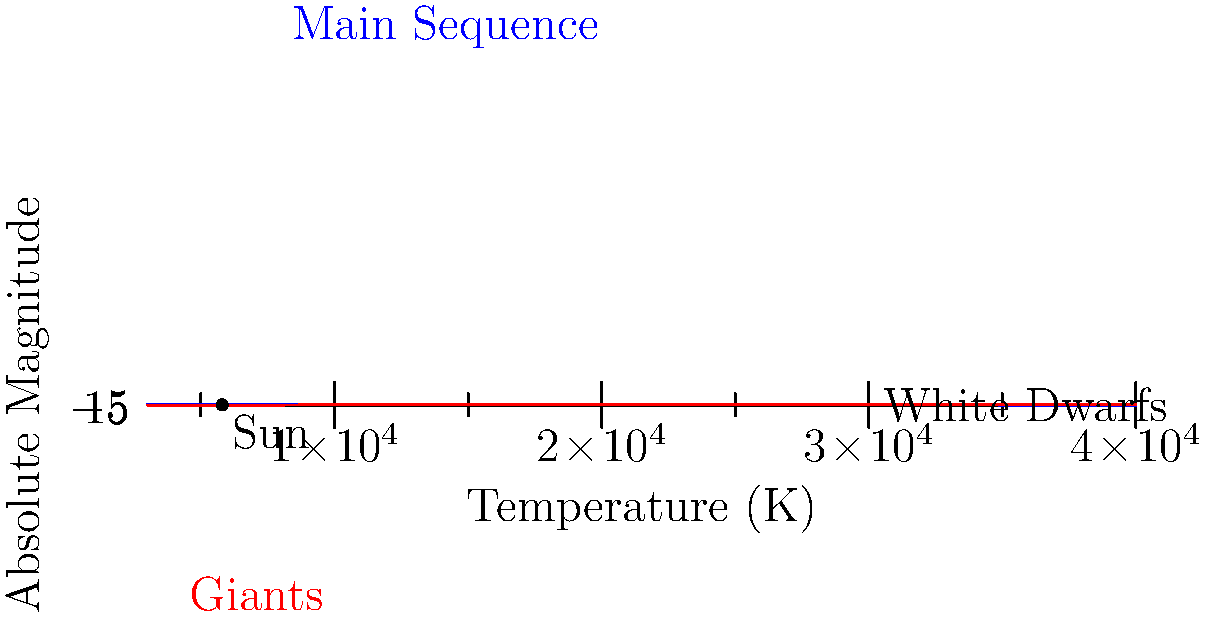In the Hertzsprung-Russell diagram shown, which stage of a star's life cycle is most likely to be misrepresented by those spreading misinformation about stellar evolution? To answer this question, we need to consider the stages of stellar evolution represented in the H-R diagram and their potential for misinterpretation:

1. Main Sequence: This is the longest and most stable phase of a star's life, where it fuses hydrogen into helium in its core. It's well-understood and less likely to be misrepresented.

2. Giant Phase: As stars evolve off the main sequence, they become larger and cooler, moving to the upper right of the diagram. This phase is more complex and could be subject to misinterpretation.

3. White Dwarf Stage: This is the final stage for low to medium-mass stars, represented in the lower left of the diagram. It's a less intuitive concept and could be misunderstood.

4. Supergiant Phase: Not explicitly labeled but would be in the upper right. This phase is dramatic and could be sensationalized.

5. Pre-main Sequence: Not shown but would be to the right of the main sequence. This early stage is less well-known and could be misrepresented.

Given the question's context of misinformation, the white dwarf stage is most likely to be misrepresented. It's counterintuitive that a star would become extremely hot yet dim, and the physics involved (electron degeneracy pressure) is complex. This could lead to misinterpretations or deliberate distortions by those seeking to spread misinformation about stellar evolution.
Answer: White dwarf stage 